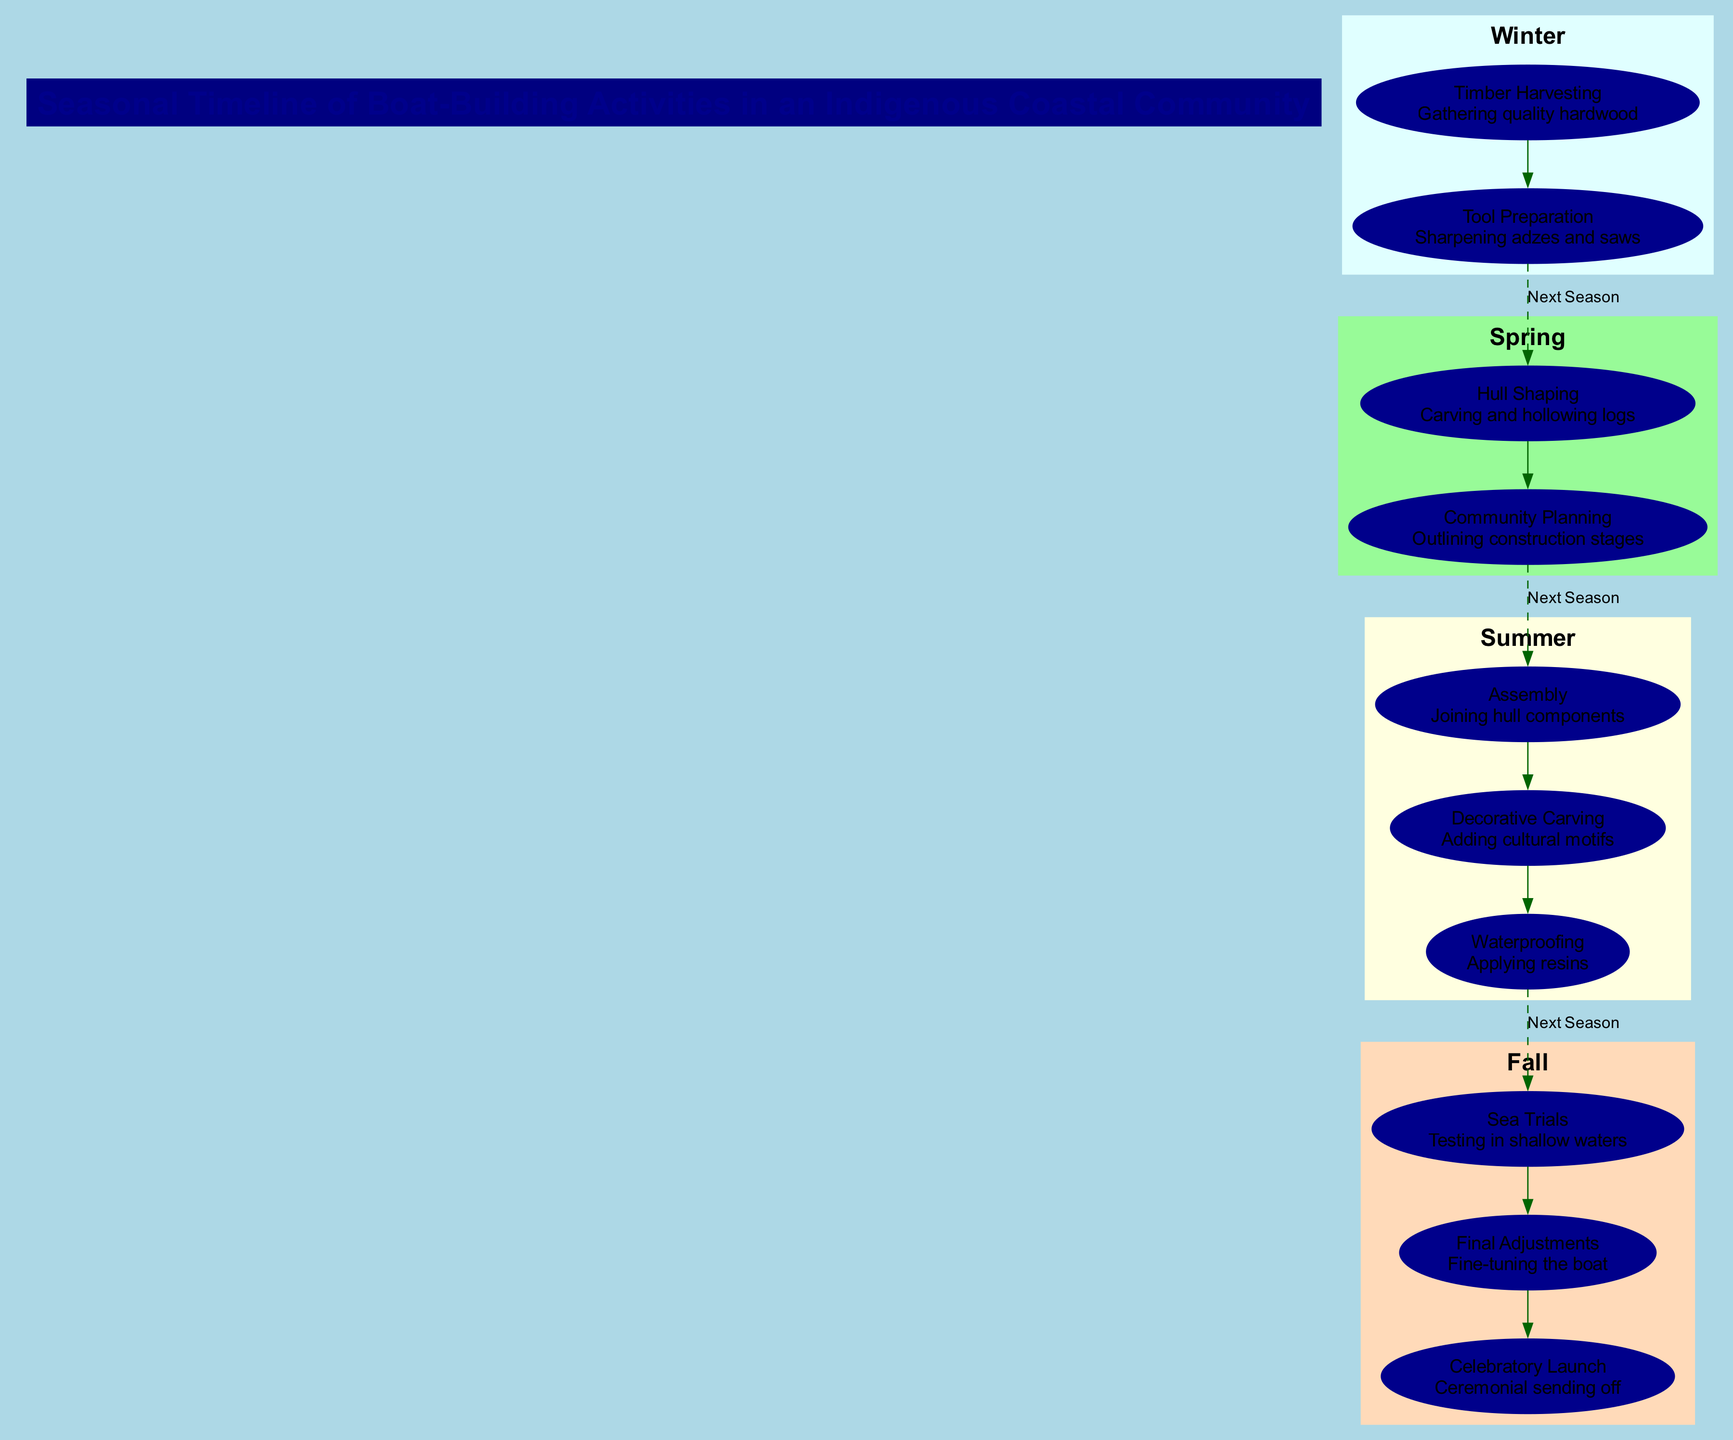What activities are included in Winter? The diagram lists two activities under Winter: Timber Harvesting and Tool Preparation.
Answer: Timber Harvesting, Tool Preparation How many activities are in the Summer season? The Summer season has three activities: Assembly, Decorative Carving, and Waterproofing.
Answer: 3 What is the last activity of Fall? According to the diagram, the last activity listed for Fall is Celebratory Launch.
Answer: Celebratory Launch What is the first activity in Spring? The first activity shown in Spring is Hull Shaping.
Answer: Hull Shaping Which activity directly follows Hull Shaping? After Hull Shaping in Spring, the next activity is Community Planning.
Answer: Community Planning How many seasons are represented in the diagram? The diagram displays four distinct seasons: Winter, Spring, Summer, and Fall.
Answer: 4 Which season contains activities related to testing boats? The activities pertaining to testing boats are included in the Fall season, specifically Sea Trials.
Answer: Fall What is a common element between Winter and Spring activities? Both Winter and Spring seasons include preparation activities: Tool Preparation in Winter and Community Planning in Spring.
Answer: Preparation Activities What seasonal activity includes applying resins? The Summer season features the activity Waterproofing, which involves applying resins.
Answer: Waterproofing 